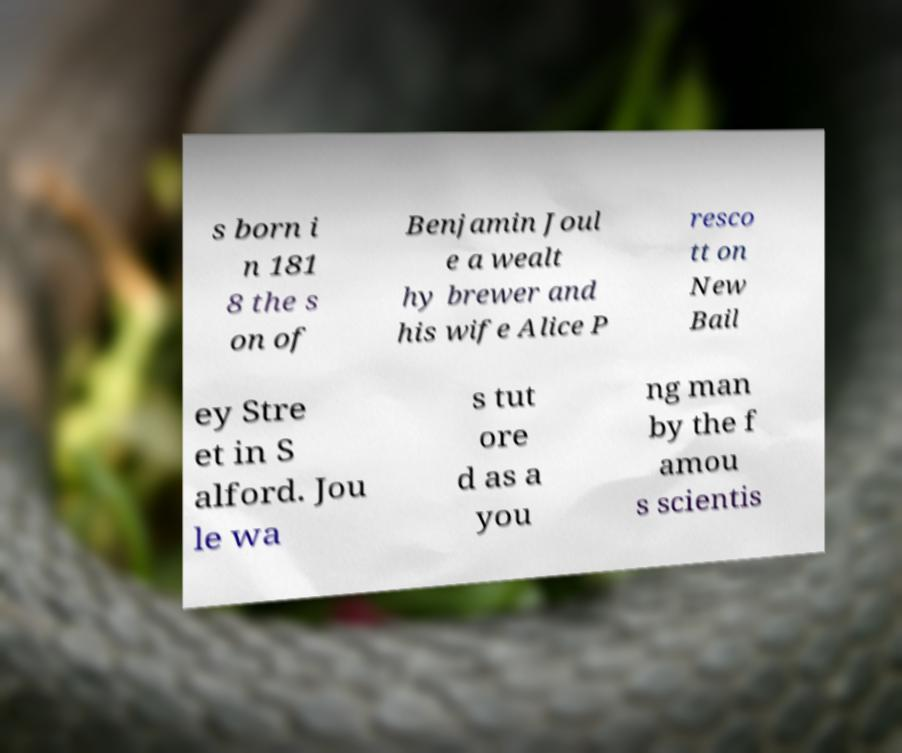Could you assist in decoding the text presented in this image and type it out clearly? s born i n 181 8 the s on of Benjamin Joul e a wealt hy brewer and his wife Alice P resco tt on New Bail ey Stre et in S alford. Jou le wa s tut ore d as a you ng man by the f amou s scientis 